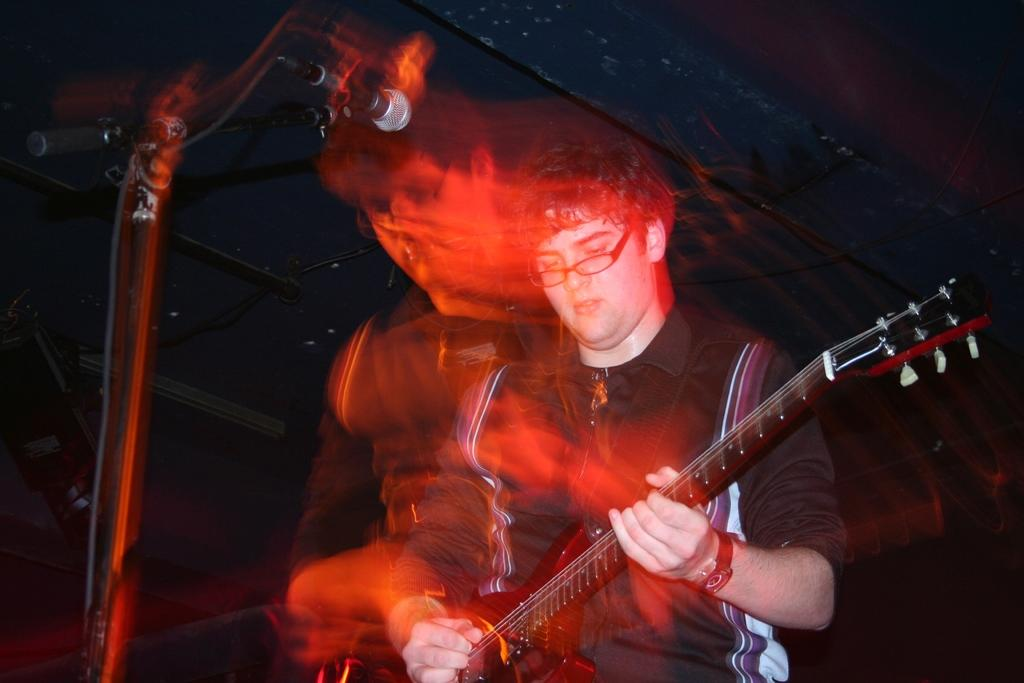What is the man in the image doing? The man is playing a guitar in the image. What object is present in the image that is commonly used for amplifying sound? There is a microphone in the image. What language is the man's aunt speaking in the image? There is no mention of an aunt or any language spoken in the image. 